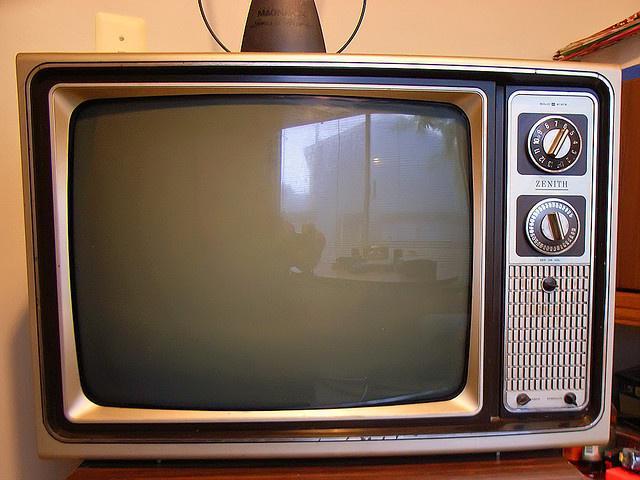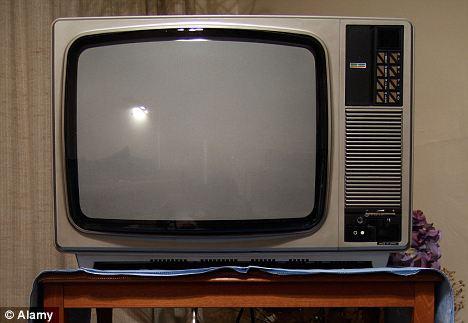The first image is the image on the left, the second image is the image on the right. For the images shown, is this caption "A frame is mounted to a wall in the image on the left." true? Answer yes or no. No. 